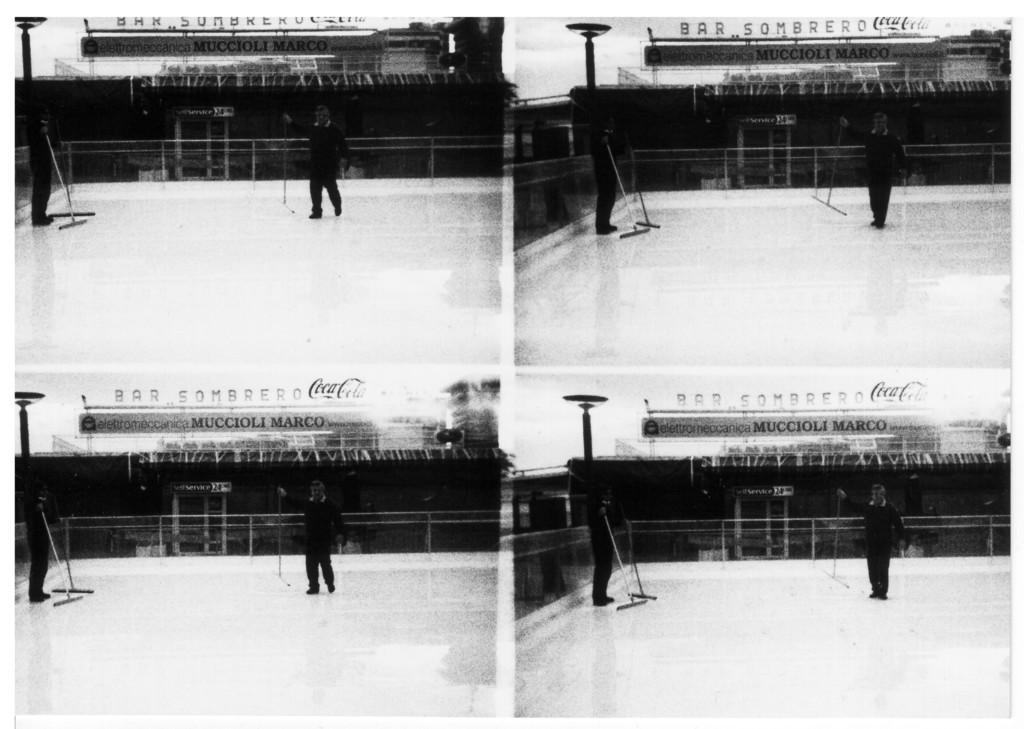What is the composition of the image? The image is a collage of four same pictures. How many people can be seen in each picture? There are two persons in each picture. What are the persons wearing in the image? The persons are wearing clothes. What is the background of the pictures? The persons are standing in front of a building. How many lizards can be seen climbing the building in the image? There are no lizards present in the image; the persons are standing in front of a building. What type of zipper can be seen on the clothes of the persons in the image? There is no specific zipper mentioned or visible on the clothes of the persons in the image. 